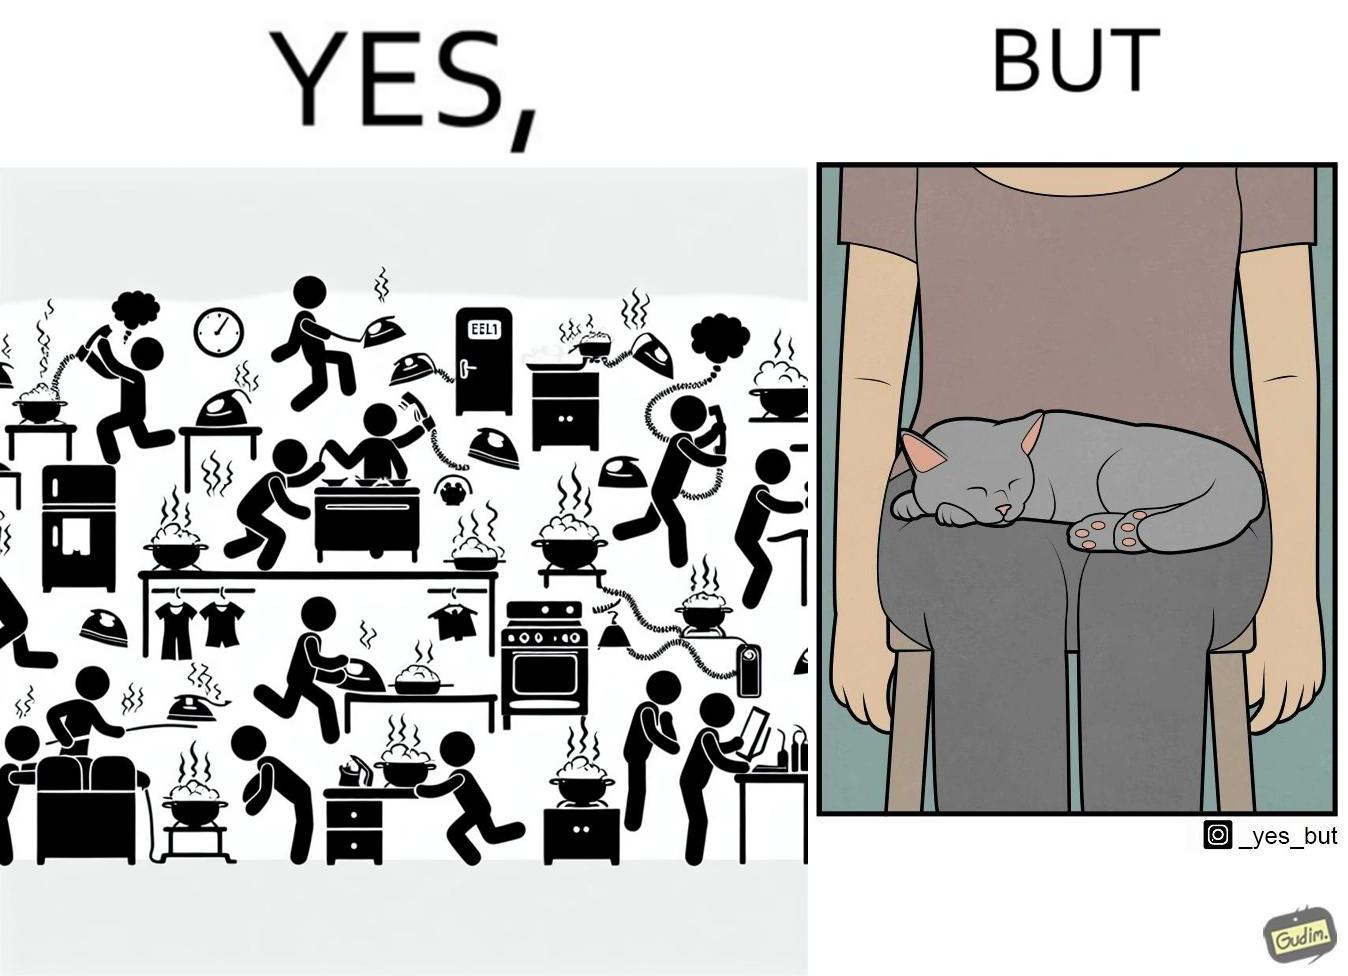Compare the left and right sides of this image. In the left part of the image: Image depicts chaos in a household with overflowing pots, ringing phone, door bell going off, and the iron burning clothes In the right part of the image: a cat sleeping on the lap of a person 